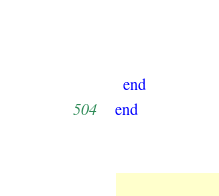Convert code to text. <code><loc_0><loc_0><loc_500><loc_500><_Ruby_>  end
end
</code> 